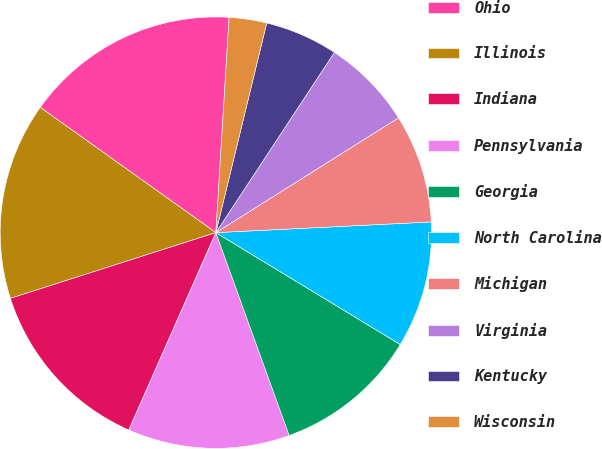Convert chart. <chart><loc_0><loc_0><loc_500><loc_500><pie_chart><fcel>Ohio<fcel>Illinois<fcel>Indiana<fcel>Pennsylvania<fcel>Georgia<fcel>North Carolina<fcel>Michigan<fcel>Virginia<fcel>Kentucky<fcel>Wisconsin<nl><fcel>16.12%<fcel>14.79%<fcel>13.46%<fcel>12.13%<fcel>10.8%<fcel>9.47%<fcel>8.14%<fcel>6.81%<fcel>5.47%<fcel>2.81%<nl></chart> 